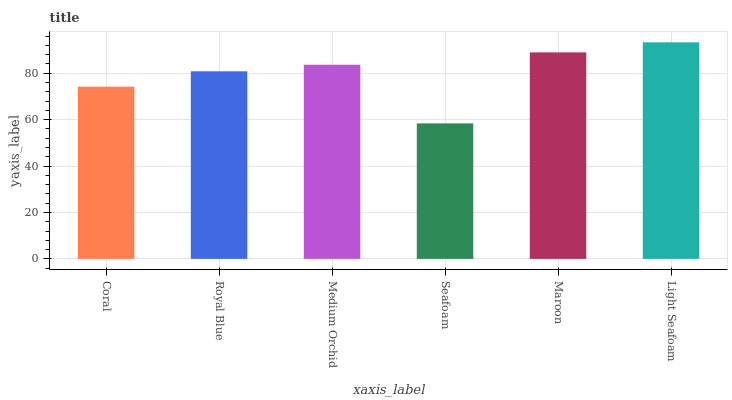Is Seafoam the minimum?
Answer yes or no. Yes. Is Light Seafoam the maximum?
Answer yes or no. Yes. Is Royal Blue the minimum?
Answer yes or no. No. Is Royal Blue the maximum?
Answer yes or no. No. Is Royal Blue greater than Coral?
Answer yes or no. Yes. Is Coral less than Royal Blue?
Answer yes or no. Yes. Is Coral greater than Royal Blue?
Answer yes or no. No. Is Royal Blue less than Coral?
Answer yes or no. No. Is Medium Orchid the high median?
Answer yes or no. Yes. Is Royal Blue the low median?
Answer yes or no. Yes. Is Royal Blue the high median?
Answer yes or no. No. Is Coral the low median?
Answer yes or no. No. 